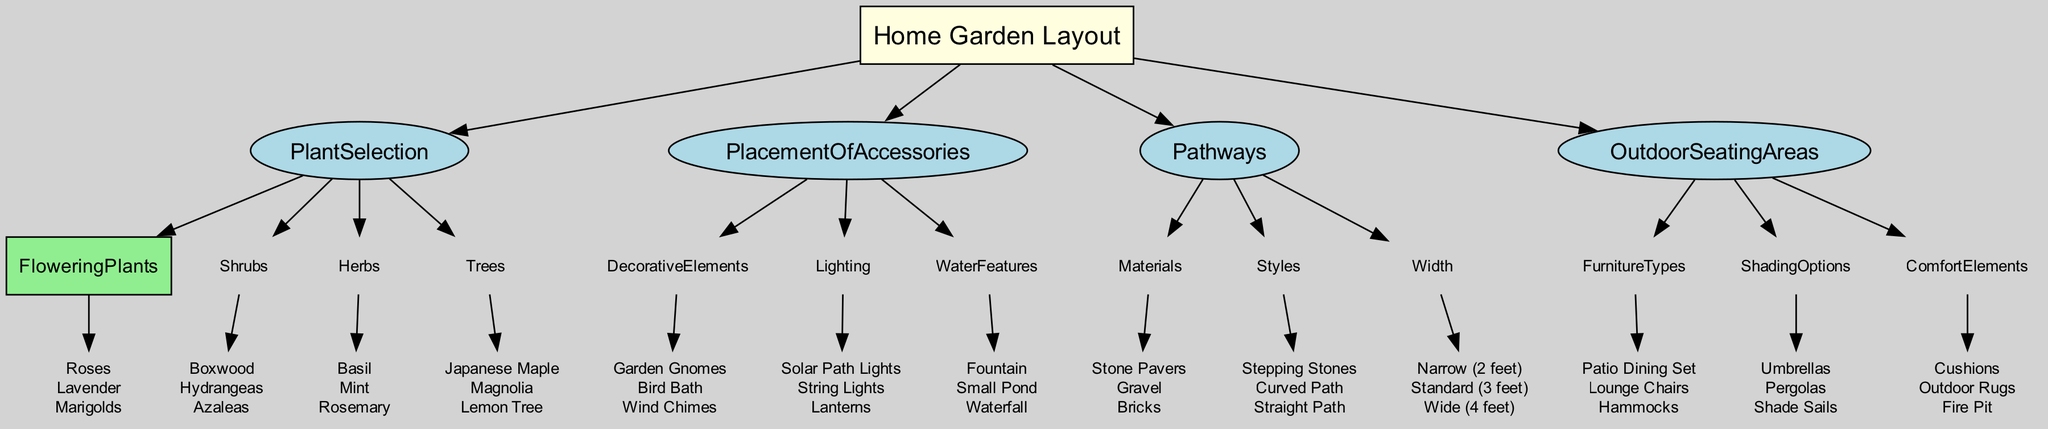What are the flowering plants listed in the diagram? The diagram lists the flowering plants under the 'PlantSelection' category. According to the visual node, the flowering plants are roses, lavender, and marigolds.
Answer: Roses, Lavender, Marigolds How many types of outdoor seating area furniture are mentioned? The outdoor seating areas section contains a list of furniture types: patio dining set, lounge chairs, and hammocks. Counting these items results in three types of outdoor seating area furniture.
Answer: 3 Which category has the least number of items? To find this, we compare the number of items in each subcategory. 'PlacementOfAccessories' has three subcategories, but upon examining each subcategory's items, 'WaterFeatures' contains only three items as well. Other categories have subcategories with more items or equal amounts.
Answer: PlacementOfAccessories What are the two shading options provided for the outdoor seating areas? The shading options are listed under 'OutdoorSeatingAreas' and specifically mention umbrellas and pergolas, along with shade sails. Focusing on just the first two options, we arrive at our answer.
Answer: Umbrellas, Pergolas What type of pathway material is suggested in the diagram? The 'Pathways' section includes a list of materials, which mentions stone pavers, gravel, and bricks. Evaluating these options confirms the materials suggested for the pathways.
Answer: Stone Pavers, Gravel, Bricks Which subcategory contains the highest number of items? To determine this, we need to count the items in all subcategories. The 'PlantSelection' category has four plant types, while others have fewer options. Therefore, 'PlantSelection' contains the highest number of items.
Answer: PlantSelection How are the decorative elements categorized in the diagram? Looking at the category 'PlacementOfAccessories', we find that decorative elements include garden gnomes, bird baths, and wind chimes. This indicates a clear categorization of decorative elements in this section.
Answer: Garden Gnomes, Bird Bath, Wind Chimes What are the styles of pathways mentioned in the diagram? The 'Pathways' category provides styles that include stepping stones, curved path, and straight path. Listing these styles gives the answer.
Answer: Stepping Stones, Curved Path, Straight Path 